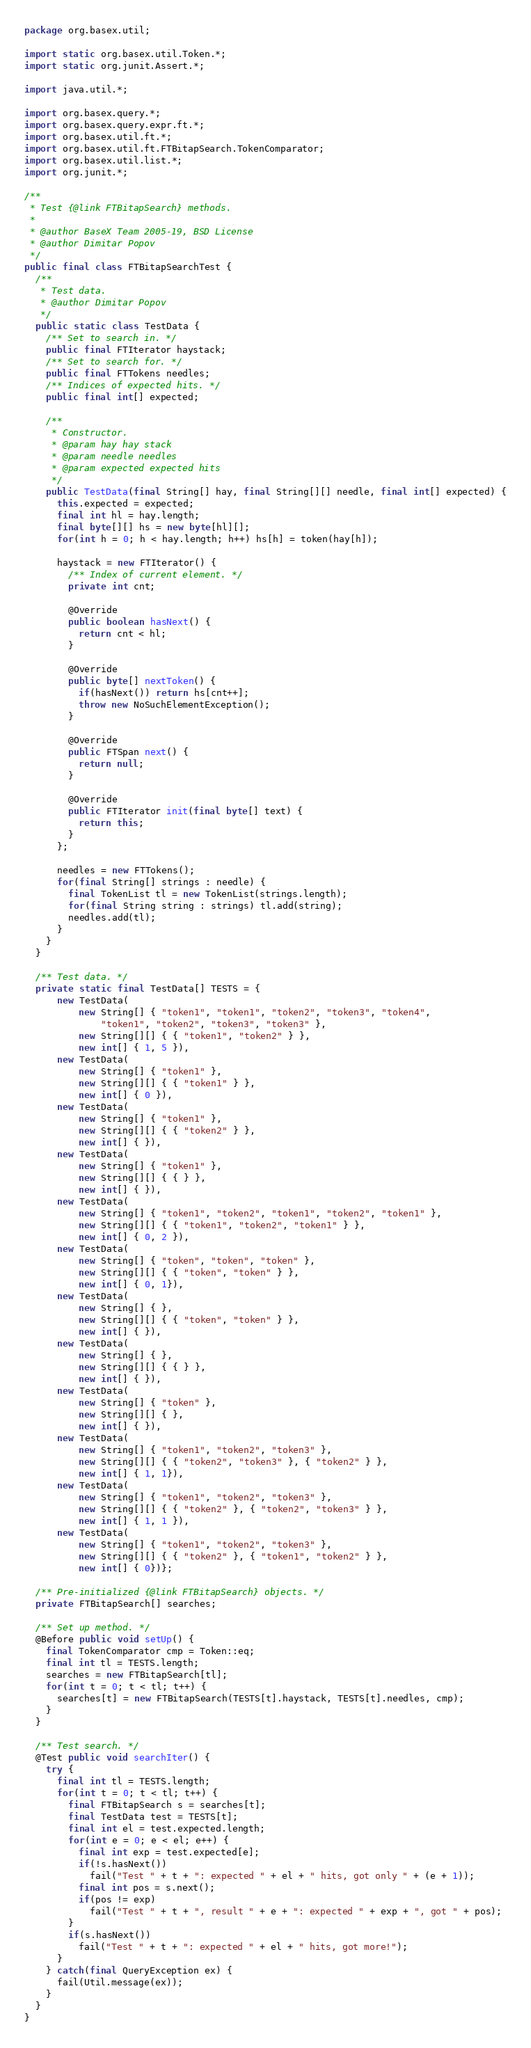Convert code to text. <code><loc_0><loc_0><loc_500><loc_500><_Java_>package org.basex.util;

import static org.basex.util.Token.*;
import static org.junit.Assert.*;

import java.util.*;

import org.basex.query.*;
import org.basex.query.expr.ft.*;
import org.basex.util.ft.*;
import org.basex.util.ft.FTBitapSearch.TokenComparator;
import org.basex.util.list.*;
import org.junit.*;

/**
 * Test {@link FTBitapSearch} methods.
 *
 * @author BaseX Team 2005-19, BSD License
 * @author Dimitar Popov
 */
public final class FTBitapSearchTest {
  /**
   * Test data.
   * @author Dimitar Popov
   */
  public static class TestData {
    /** Set to search in. */
    public final FTIterator haystack;
    /** Set to search for. */
    public final FTTokens needles;
    /** Indices of expected hits. */
    public final int[] expected;

    /**
     * Constructor.
     * @param hay hay stack
     * @param needle needles
     * @param expected expected hits
     */
    public TestData(final String[] hay, final String[][] needle, final int[] expected) {
      this.expected = expected;
      final int hl = hay.length;
      final byte[][] hs = new byte[hl][];
      for(int h = 0; h < hay.length; h++) hs[h] = token(hay[h]);

      haystack = new FTIterator() {
        /** Index of current element. */
        private int cnt;

        @Override
        public boolean hasNext() {
          return cnt < hl;
        }

        @Override
        public byte[] nextToken() {
          if(hasNext()) return hs[cnt++];
          throw new NoSuchElementException();
        }

        @Override
        public FTSpan next() {
          return null;
        }

        @Override
        public FTIterator init(final byte[] text) {
          return this;
        }
      };

      needles = new FTTokens();
      for(final String[] strings : needle) {
        final TokenList tl = new TokenList(strings.length);
        for(final String string : strings) tl.add(string);
        needles.add(tl);
      }
    }
  }

  /** Test data. */
  private static final TestData[] TESTS = {
      new TestData(
          new String[] { "token1", "token1", "token2", "token3", "token4",
              "token1", "token2", "token3", "token3" },
          new String[][] { { "token1", "token2" } },
          new int[] { 1, 5 }),
      new TestData(
          new String[] { "token1" },
          new String[][] { { "token1" } },
          new int[] { 0 }),
      new TestData(
          new String[] { "token1" },
          new String[][] { { "token2" } },
          new int[] { }),
      new TestData(
          new String[] { "token1" },
          new String[][] { { } },
          new int[] { }),
      new TestData(
          new String[] { "token1", "token2", "token1", "token2", "token1" },
          new String[][] { { "token1", "token2", "token1" } },
          new int[] { 0, 2 }),
      new TestData(
          new String[] { "token", "token", "token" },
          new String[][] { { "token", "token" } },
          new int[] { 0, 1}),
      new TestData(
          new String[] { },
          new String[][] { { "token", "token" } },
          new int[] { }),
      new TestData(
          new String[] { },
          new String[][] { { } },
          new int[] { }),
      new TestData(
          new String[] { "token" },
          new String[][] { },
          new int[] { }),
      new TestData(
          new String[] { "token1", "token2", "token3" },
          new String[][] { { "token2", "token3" }, { "token2" } },
          new int[] { 1, 1}),
      new TestData(
          new String[] { "token1", "token2", "token3" },
          new String[][] { { "token2" }, { "token2", "token3" } },
          new int[] { 1, 1 }),
      new TestData(
          new String[] { "token1", "token2", "token3" },
          new String[][] { { "token2" }, { "token1", "token2" } },
          new int[] { 0})};

  /** Pre-initialized {@link FTBitapSearch} objects. */
  private FTBitapSearch[] searches;

  /** Set up method. */
  @Before public void setUp() {
    final TokenComparator cmp = Token::eq;
    final int tl = TESTS.length;
    searches = new FTBitapSearch[tl];
    for(int t = 0; t < tl; t++) {
      searches[t] = new FTBitapSearch(TESTS[t].haystack, TESTS[t].needles, cmp);
    }
  }

  /** Test search. */
  @Test public void searchIter() {
    try {
      final int tl = TESTS.length;
      for(int t = 0; t < tl; t++) {
        final FTBitapSearch s = searches[t];
        final TestData test = TESTS[t];
        final int el = test.expected.length;
        for(int e = 0; e < el; e++) {
          final int exp = test.expected[e];
          if(!s.hasNext())
            fail("Test " + t + ": expected " + el + " hits, got only " + (e + 1));
          final int pos = s.next();
          if(pos != exp)
            fail("Test " + t + ", result " + e + ": expected " + exp + ", got " + pos);
        }
        if(s.hasNext())
          fail("Test " + t + ": expected " + el + " hits, got more!");
      }
    } catch(final QueryException ex) {
      fail(Util.message(ex));
    }
  }
}
</code> 